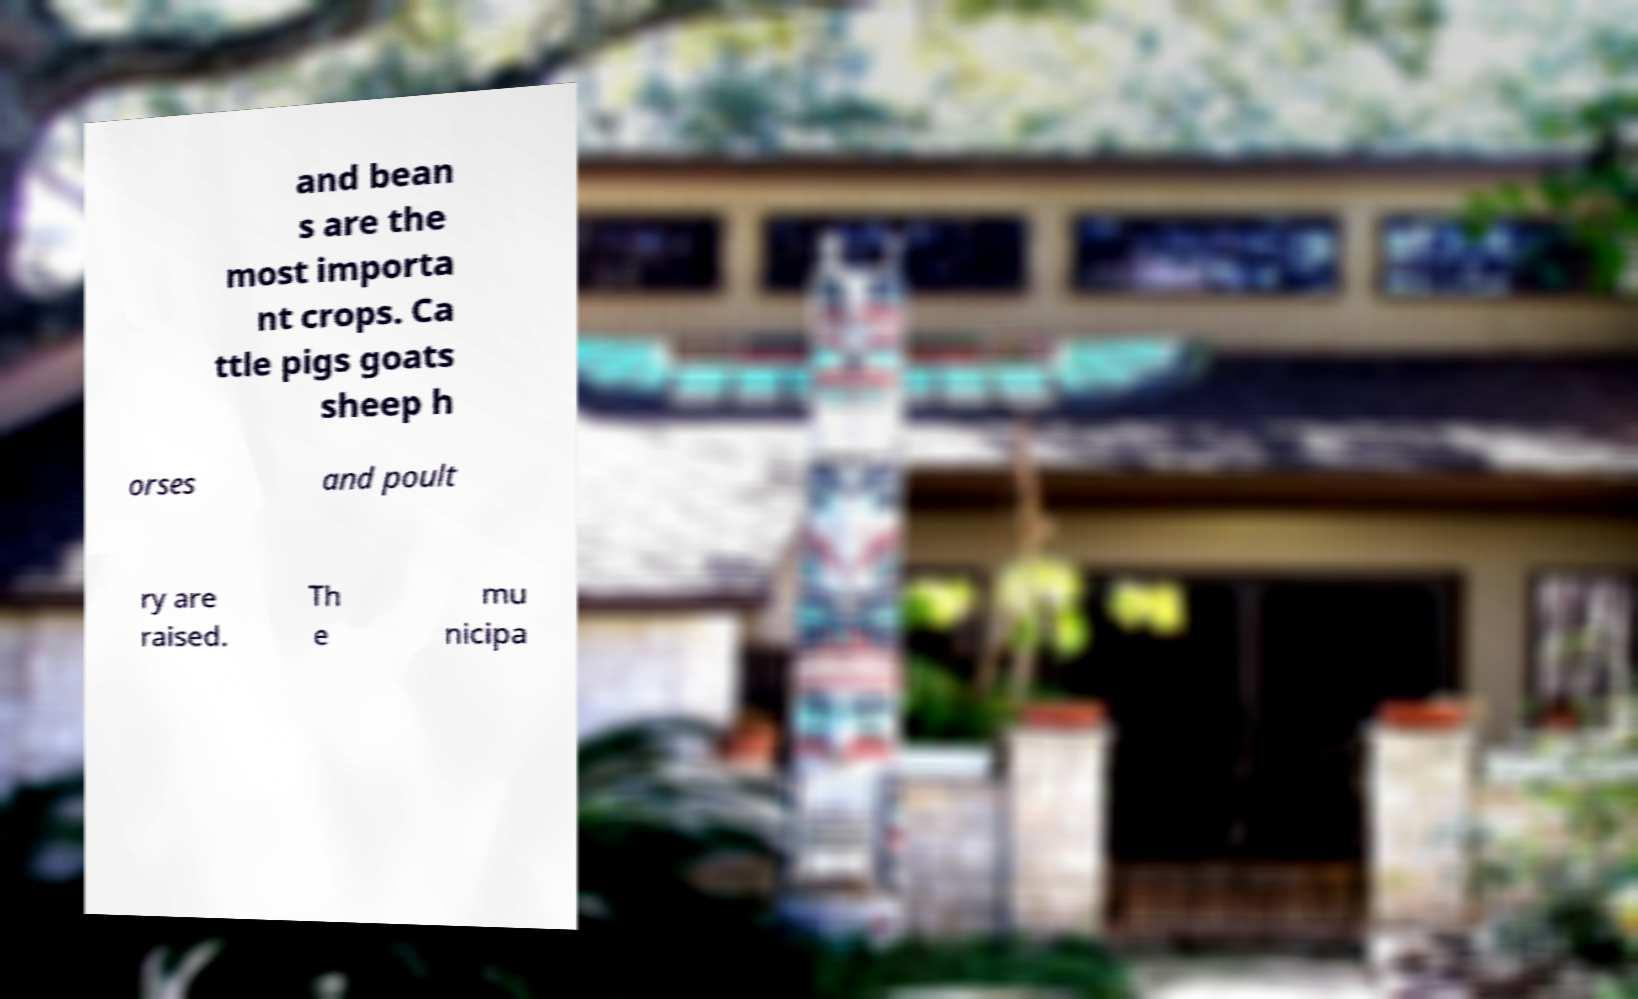Could you extract and type out the text from this image? and bean s are the most importa nt crops. Ca ttle pigs goats sheep h orses and poult ry are raised. Th e mu nicipa 